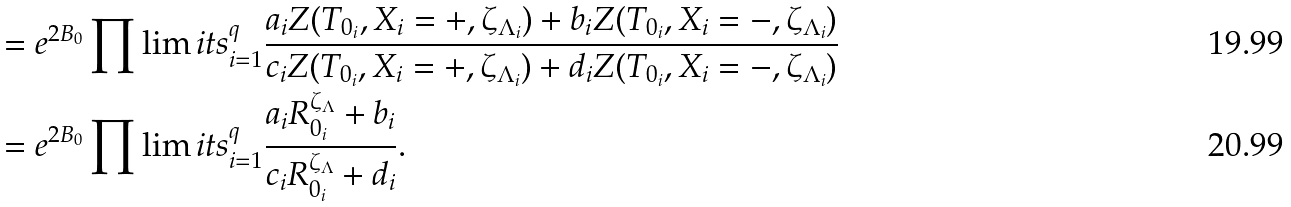Convert formula to latex. <formula><loc_0><loc_0><loc_500><loc_500>& = e ^ { 2 B _ { 0 } } \prod \lim i t s ^ { q } _ { i = 1 } \frac { a _ { i } Z ( T _ { 0 _ { i } } , X _ { i } = + , \zeta _ { \Lambda _ { i } } ) + b _ { i } Z ( T _ { 0 _ { i } } , X _ { i } = - , \zeta _ { \Lambda _ { i } } ) } { c _ { i } Z ( T _ { 0 _ { i } } , X _ { i } = + , \zeta _ { \Lambda _ { i } } ) + d _ { i } Z ( T _ { 0 _ { i } } , X _ { i } = - , \zeta _ { \Lambda _ { i } } ) } \\ & = e ^ { 2 B _ { 0 } } \prod \lim i t s ^ { q } _ { i = 1 } \frac { a _ { i } R ^ { \zeta _ { \Lambda } } _ { 0 _ { i } } + b _ { i } } { c _ { i } R ^ { \zeta _ { \Lambda } } _ { 0 _ { i } } + d _ { i } } .</formula> 